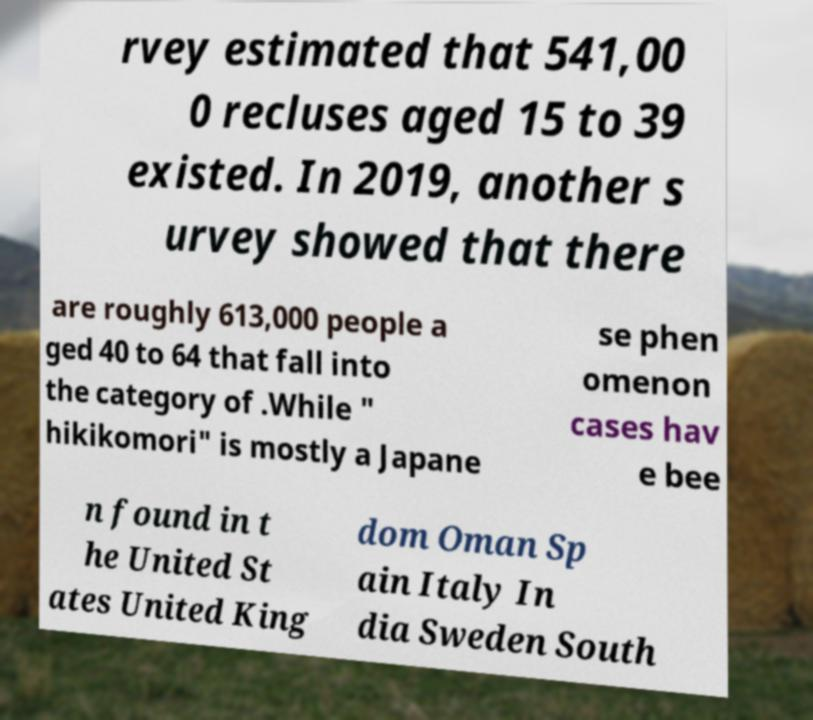Can you read and provide the text displayed in the image?This photo seems to have some interesting text. Can you extract and type it out for me? rvey estimated that 541,00 0 recluses aged 15 to 39 existed. In 2019, another s urvey showed that there are roughly 613,000 people a ged 40 to 64 that fall into the category of .While " hikikomori" is mostly a Japane se phen omenon cases hav e bee n found in t he United St ates United King dom Oman Sp ain Italy In dia Sweden South 